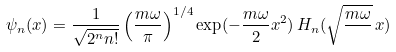Convert formula to latex. <formula><loc_0><loc_0><loc_500><loc_500>\psi _ { n } ( x ) = \frac { 1 } { \sqrt { 2 ^ { n } n ! } } \left ( \frac { m \omega } { \pi } \right ) ^ { 1 / 4 } \exp ( - \frac { m \omega } { 2 } x ^ { 2 } ) \, H _ { n } ( \sqrt { \frac { m \omega } { } } \, x )</formula> 